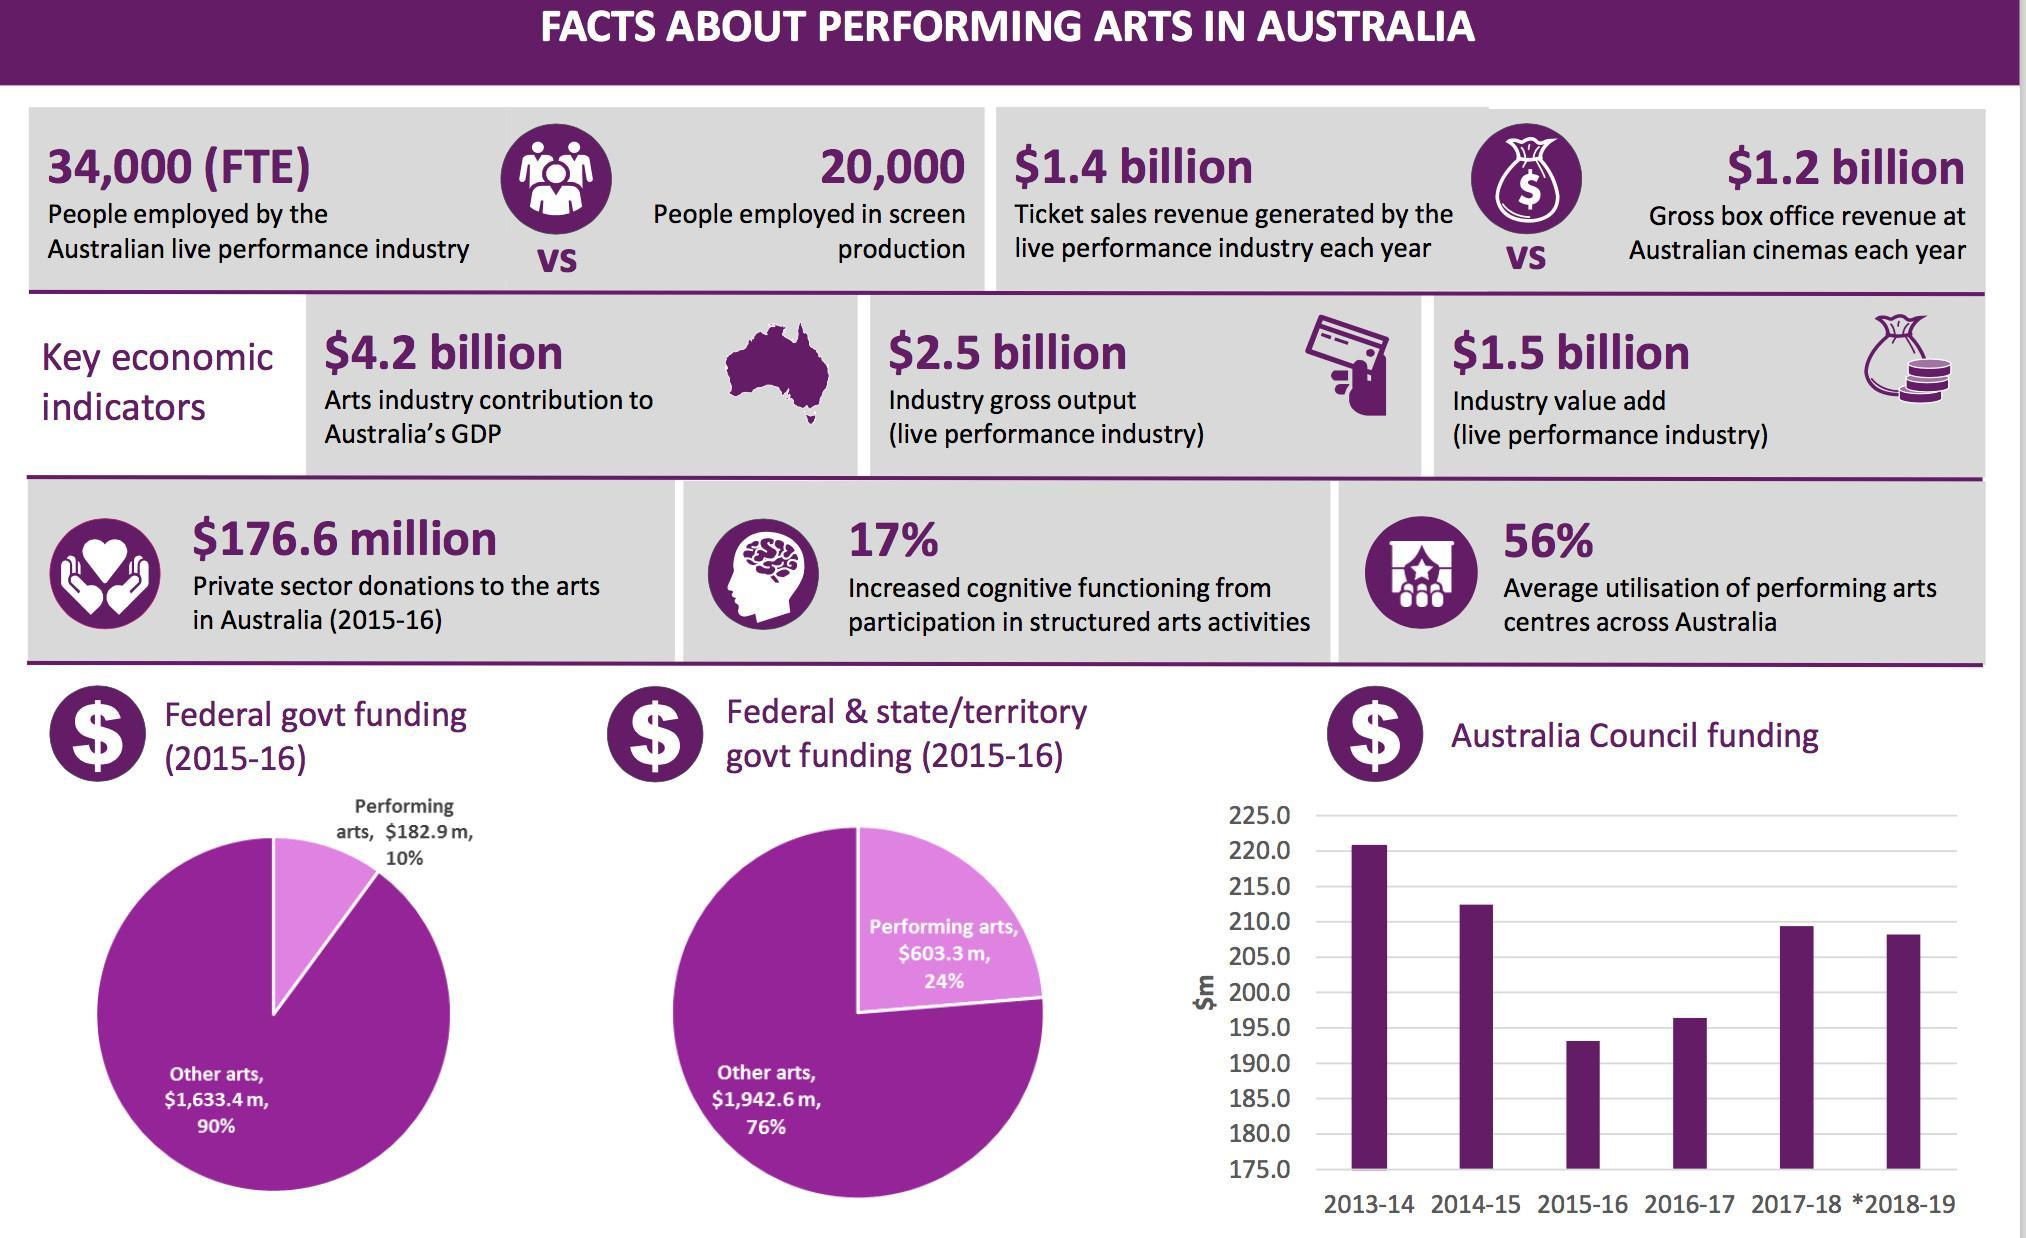During which year was Australia Council Funding the highest?
Answer the question with a short phrase. 2013-14 In which year was the Australia Council Funding below 195m $? 2015-16 What percentage of performing art centres are not utilised in Australia? 44% 